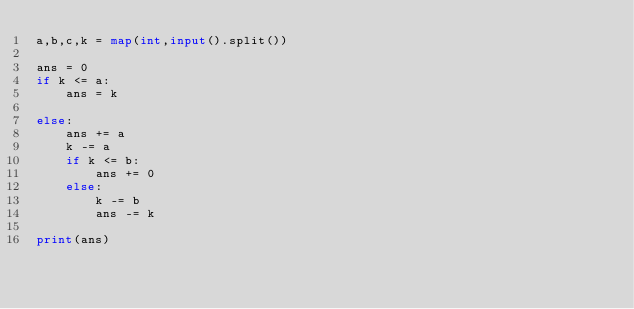<code> <loc_0><loc_0><loc_500><loc_500><_Python_>a,b,c,k = map(int,input().split())

ans = 0
if k <= a:
    ans = k

else:
    ans += a
    k -= a
    if k <= b:
        ans += 0
    else:
        k -= b
        ans -= k

print(ans)</code> 